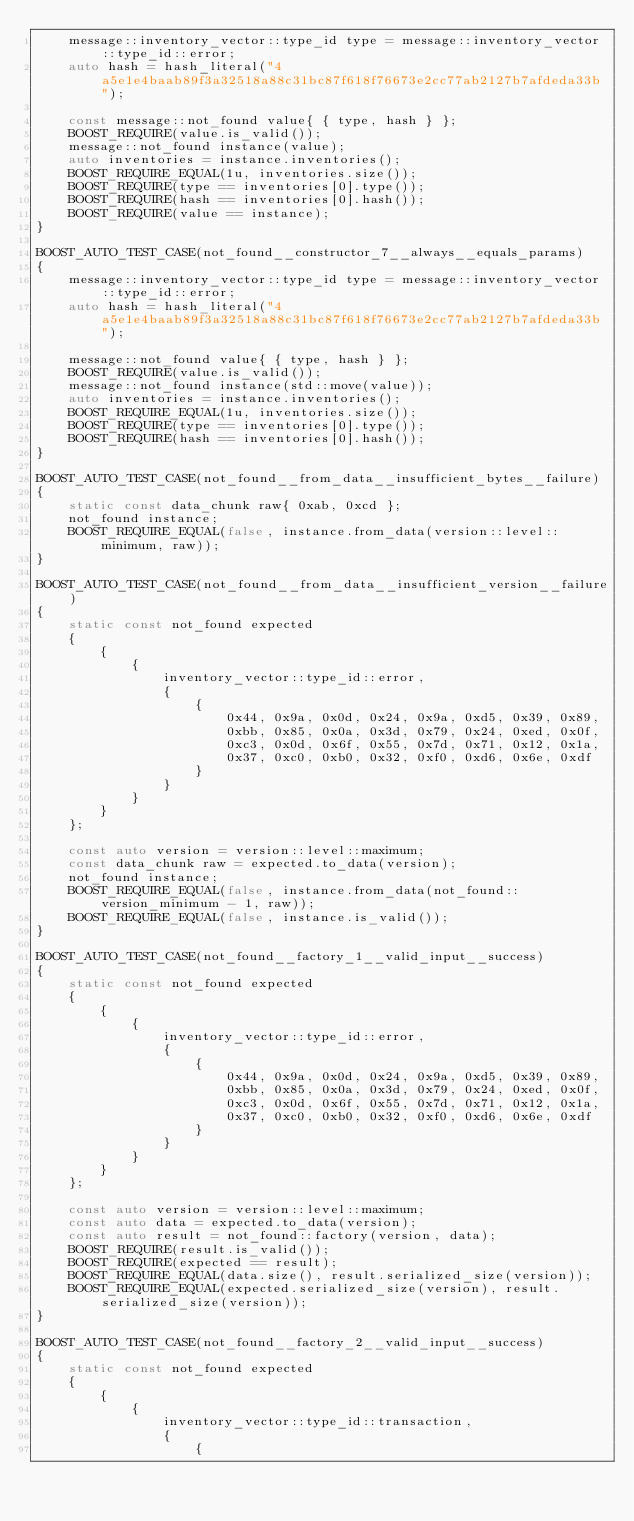<code> <loc_0><loc_0><loc_500><loc_500><_C++_>    message::inventory_vector::type_id type = message::inventory_vector::type_id::error;
    auto hash = hash_literal("4a5e1e4baab89f3a32518a88c31bc87f618f76673e2cc77ab2127b7afdeda33b");

    const message::not_found value{ { type, hash } };
    BOOST_REQUIRE(value.is_valid());
    message::not_found instance(value);
    auto inventories = instance.inventories();
    BOOST_REQUIRE_EQUAL(1u, inventories.size());
    BOOST_REQUIRE(type == inventories[0].type());
    BOOST_REQUIRE(hash == inventories[0].hash());
    BOOST_REQUIRE(value == instance);
}

BOOST_AUTO_TEST_CASE(not_found__constructor_7__always__equals_params)
{
    message::inventory_vector::type_id type = message::inventory_vector::type_id::error;
    auto hash = hash_literal("4a5e1e4baab89f3a32518a88c31bc87f618f76673e2cc77ab2127b7afdeda33b");

    message::not_found value{ { type, hash } };
    BOOST_REQUIRE(value.is_valid());
    message::not_found instance(std::move(value));
    auto inventories = instance.inventories();
    BOOST_REQUIRE_EQUAL(1u, inventories.size());
    BOOST_REQUIRE(type == inventories[0].type());
    BOOST_REQUIRE(hash == inventories[0].hash());
}

BOOST_AUTO_TEST_CASE(not_found__from_data__insufficient_bytes__failure)
{
    static const data_chunk raw{ 0xab, 0xcd };
    not_found instance;
    BOOST_REQUIRE_EQUAL(false, instance.from_data(version::level::minimum, raw));
}

BOOST_AUTO_TEST_CASE(not_found__from_data__insufficient_version__failure)
{
    static const not_found expected
    {
        {
            {
                inventory_vector::type_id::error,
                {
                    {
                        0x44, 0x9a, 0x0d, 0x24, 0x9a, 0xd5, 0x39, 0x89,
                        0xbb, 0x85, 0x0a, 0x3d, 0x79, 0x24, 0xed, 0x0f,
                        0xc3, 0x0d, 0x6f, 0x55, 0x7d, 0x71, 0x12, 0x1a,
                        0x37, 0xc0, 0xb0, 0x32, 0xf0, 0xd6, 0x6e, 0xdf
                    }
                }
            }
        }
    };

    const auto version = version::level::maximum;
    const data_chunk raw = expected.to_data(version);
    not_found instance;
    BOOST_REQUIRE_EQUAL(false, instance.from_data(not_found::version_minimum - 1, raw));
    BOOST_REQUIRE_EQUAL(false, instance.is_valid());
}

BOOST_AUTO_TEST_CASE(not_found__factory_1__valid_input__success)
{
    static const not_found expected
    {
        {
            {
                inventory_vector::type_id::error,
                {
                    {
                        0x44, 0x9a, 0x0d, 0x24, 0x9a, 0xd5, 0x39, 0x89,
                        0xbb, 0x85, 0x0a, 0x3d, 0x79, 0x24, 0xed, 0x0f,
                        0xc3, 0x0d, 0x6f, 0x55, 0x7d, 0x71, 0x12, 0x1a,
                        0x37, 0xc0, 0xb0, 0x32, 0xf0, 0xd6, 0x6e, 0xdf
                    }
                }
            }
        }
    };

    const auto version = version::level::maximum;
    const auto data = expected.to_data(version);
    const auto result = not_found::factory(version, data);
    BOOST_REQUIRE(result.is_valid());
    BOOST_REQUIRE(expected == result);
    BOOST_REQUIRE_EQUAL(data.size(), result.serialized_size(version));
    BOOST_REQUIRE_EQUAL(expected.serialized_size(version), result.serialized_size(version));
}

BOOST_AUTO_TEST_CASE(not_found__factory_2__valid_input__success)
{
    static const not_found expected
    {
        {
            {
                inventory_vector::type_id::transaction,
                {
                    {</code> 